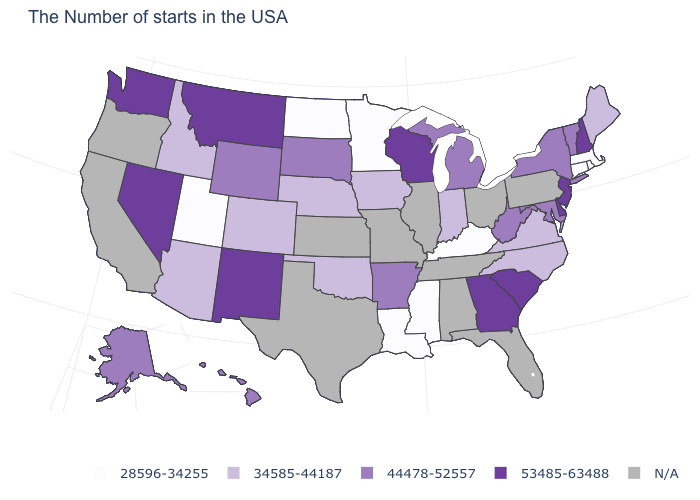What is the highest value in the USA?
Quick response, please. 53485-63488. How many symbols are there in the legend?
Short answer required. 5. What is the value of Ohio?
Quick response, please. N/A. What is the highest value in the USA?
Give a very brief answer. 53485-63488. Which states have the highest value in the USA?
Give a very brief answer. New Hampshire, New Jersey, Delaware, South Carolina, Georgia, Wisconsin, New Mexico, Montana, Nevada, Washington. Which states have the highest value in the USA?
Answer briefly. New Hampshire, New Jersey, Delaware, South Carolina, Georgia, Wisconsin, New Mexico, Montana, Nevada, Washington. Is the legend a continuous bar?
Quick response, please. No. What is the lowest value in the USA?
Short answer required. 28596-34255. Which states have the lowest value in the USA?
Concise answer only. Massachusetts, Rhode Island, Connecticut, Kentucky, Mississippi, Louisiana, Minnesota, North Dakota, Utah. What is the value of Rhode Island?
Be succinct. 28596-34255. Name the states that have a value in the range 53485-63488?
Give a very brief answer. New Hampshire, New Jersey, Delaware, South Carolina, Georgia, Wisconsin, New Mexico, Montana, Nevada, Washington. Name the states that have a value in the range 28596-34255?
Quick response, please. Massachusetts, Rhode Island, Connecticut, Kentucky, Mississippi, Louisiana, Minnesota, North Dakota, Utah. Name the states that have a value in the range 28596-34255?
Keep it brief. Massachusetts, Rhode Island, Connecticut, Kentucky, Mississippi, Louisiana, Minnesota, North Dakota, Utah. Does West Virginia have the lowest value in the USA?
Answer briefly. No. 